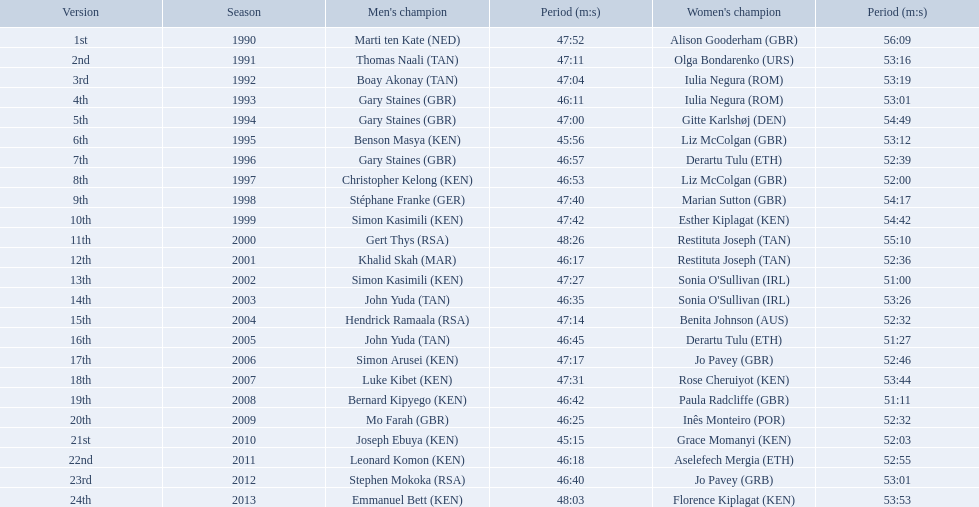What years were the races held? 1990, 1991, 1992, 1993, 1994, 1995, 1996, 1997, 1998, 1999, 2000, 2001, 2002, 2003, 2004, 2005, 2006, 2007, 2008, 2009, 2010, 2011, 2012, 2013. Who was the woman's winner of the 2003 race? Sonia O'Sullivan (IRL). What was her time? 53:26. Which of the runner in the great south run were women? Alison Gooderham (GBR), Olga Bondarenko (URS), Iulia Negura (ROM), Iulia Negura (ROM), Gitte Karlshøj (DEN), Liz McColgan (GBR), Derartu Tulu (ETH), Liz McColgan (GBR), Marian Sutton (GBR), Esther Kiplagat (KEN), Restituta Joseph (TAN), Restituta Joseph (TAN), Sonia O'Sullivan (IRL), Sonia O'Sullivan (IRL), Benita Johnson (AUS), Derartu Tulu (ETH), Jo Pavey (GBR), Rose Cheruiyot (KEN), Paula Radcliffe (GBR), Inês Monteiro (POR), Grace Momanyi (KEN), Aselefech Mergia (ETH), Jo Pavey (GRB), Florence Kiplagat (KEN). Of those women, which ones had a time of at least 53 minutes? Alison Gooderham (GBR), Olga Bondarenko (URS), Iulia Negura (ROM), Iulia Negura (ROM), Gitte Karlshøj (DEN), Liz McColgan (GBR), Marian Sutton (GBR), Esther Kiplagat (KEN), Restituta Joseph (TAN), Sonia O'Sullivan (IRL), Rose Cheruiyot (KEN), Jo Pavey (GRB), Florence Kiplagat (KEN). Between those women, which ones did not go over 53 minutes? Olga Bondarenko (URS), Iulia Negura (ROM), Iulia Negura (ROM), Liz McColgan (GBR), Sonia O'Sullivan (IRL), Rose Cheruiyot (KEN), Jo Pavey (GRB), Florence Kiplagat (KEN). Of those 8, what were the three slowest times? Sonia O'Sullivan (IRL), Rose Cheruiyot (KEN), Florence Kiplagat (KEN). Between only those 3 women, which runner had the fastest time? Sonia O'Sullivan (IRL). What was this women's time? 53:26. What place did sonia o'sullivan finish in 2003? 14th. How long did it take her to finish? 53:26. 